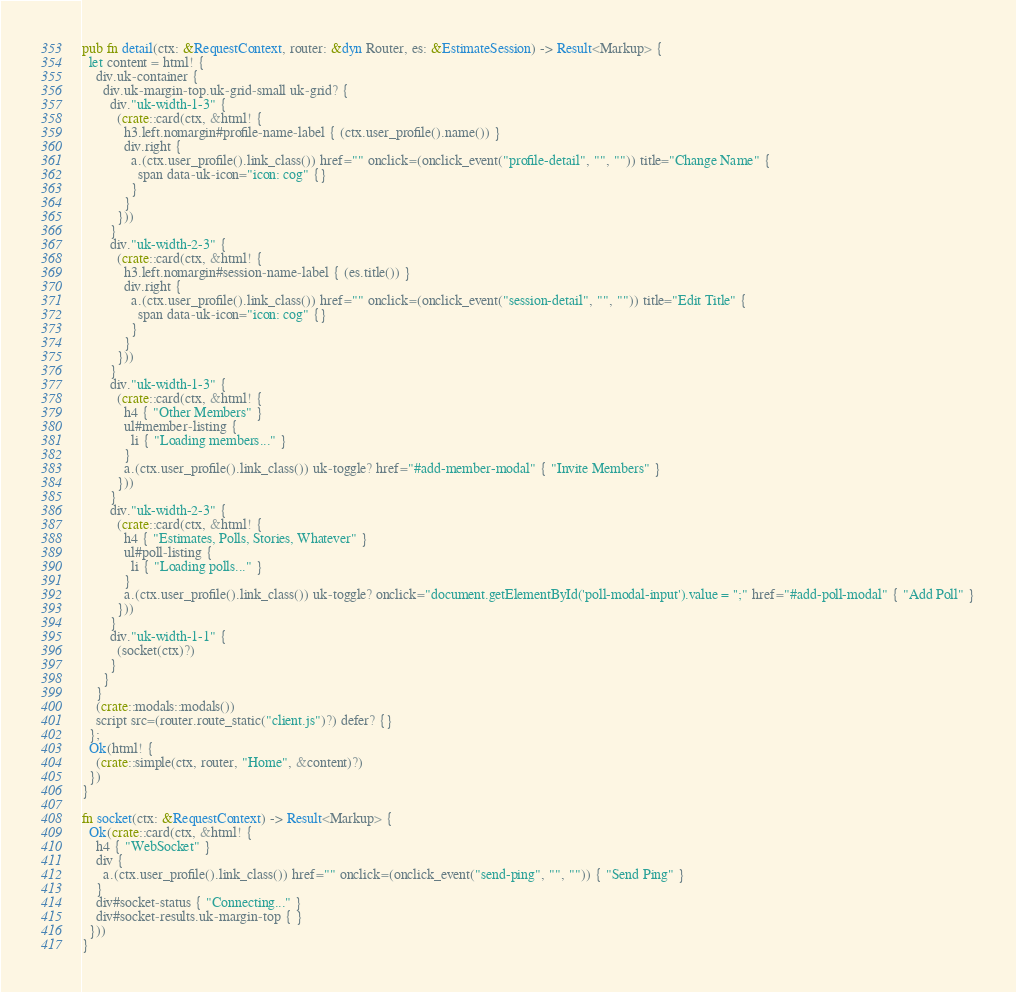<code> <loc_0><loc_0><loc_500><loc_500><_Rust_>
pub fn detail(ctx: &RequestContext, router: &dyn Router, es: &EstimateSession) -> Result<Markup> {
  let content = html! {
    div.uk-container {
      div.uk-margin-top.uk-grid-small uk-grid? {
        div."uk-width-1-3" {
          (crate::card(ctx, &html! {
            h3.left.nomargin#profile-name-label { (ctx.user_profile().name()) }
            div.right {
              a.(ctx.user_profile().link_class()) href="" onclick=(onclick_event("profile-detail", "", "")) title="Change Name" {
                span data-uk-icon="icon: cog" {}
              }
            }
          }))
        }
        div."uk-width-2-3" {
          (crate::card(ctx, &html! {
            h3.left.nomargin#session-name-label { (es.title()) }
            div.right {
              a.(ctx.user_profile().link_class()) href="" onclick=(onclick_event("session-detail", "", "")) title="Edit Title" {
                span data-uk-icon="icon: cog" {}
              }
            }
          }))
        }
        div."uk-width-1-3" {
          (crate::card(ctx, &html! {
            h4 { "Other Members" }
            ul#member-listing {
              li { "Loading members..." }
            }
            a.(ctx.user_profile().link_class()) uk-toggle? href="#add-member-modal" { "Invite Members" }
          }))
        }
        div."uk-width-2-3" {
          (crate::card(ctx, &html! {
            h4 { "Estimates, Polls, Stories, Whatever" }
            ul#poll-listing {
              li { "Loading polls..." }
            }
            a.(ctx.user_profile().link_class()) uk-toggle? onclick="document.getElementById('poll-modal-input').value = '';" href="#add-poll-modal" { "Add Poll" }
          }))
        }
        div."uk-width-1-1" {
          (socket(ctx)?)
        }
      }
    }
    (crate::modals::modals())
    script src=(router.route_static("client.js")?) defer? {}
  };
  Ok(html! {
    (crate::simple(ctx, router, "Home", &content)?)
  })
}

fn socket(ctx: &RequestContext) -> Result<Markup> {
  Ok(crate::card(ctx, &html! {
    h4 { "WebSocket" }
    div {
      a.(ctx.user_profile().link_class()) href="" onclick=(onclick_event("send-ping", "", "")) { "Send Ping" }
    }
    div#socket-status { "Connecting..." }
    div#socket-results.uk-margin-top { }
  }))
}
</code> 